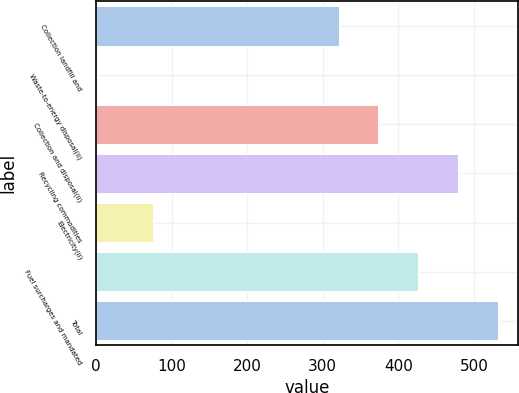Convert chart to OTSL. <chart><loc_0><loc_0><loc_500><loc_500><bar_chart><fcel>Collection landfill and<fcel>Waste-to-energy disposal(ii)<fcel>Collection and disposal(ii)<fcel>Recycling commodities<fcel>Electricity(ii)<fcel>Fuel surcharges and mandated<fcel>Total<nl><fcel>321<fcel>2<fcel>373.6<fcel>478.8<fcel>76<fcel>426.2<fcel>531.4<nl></chart> 